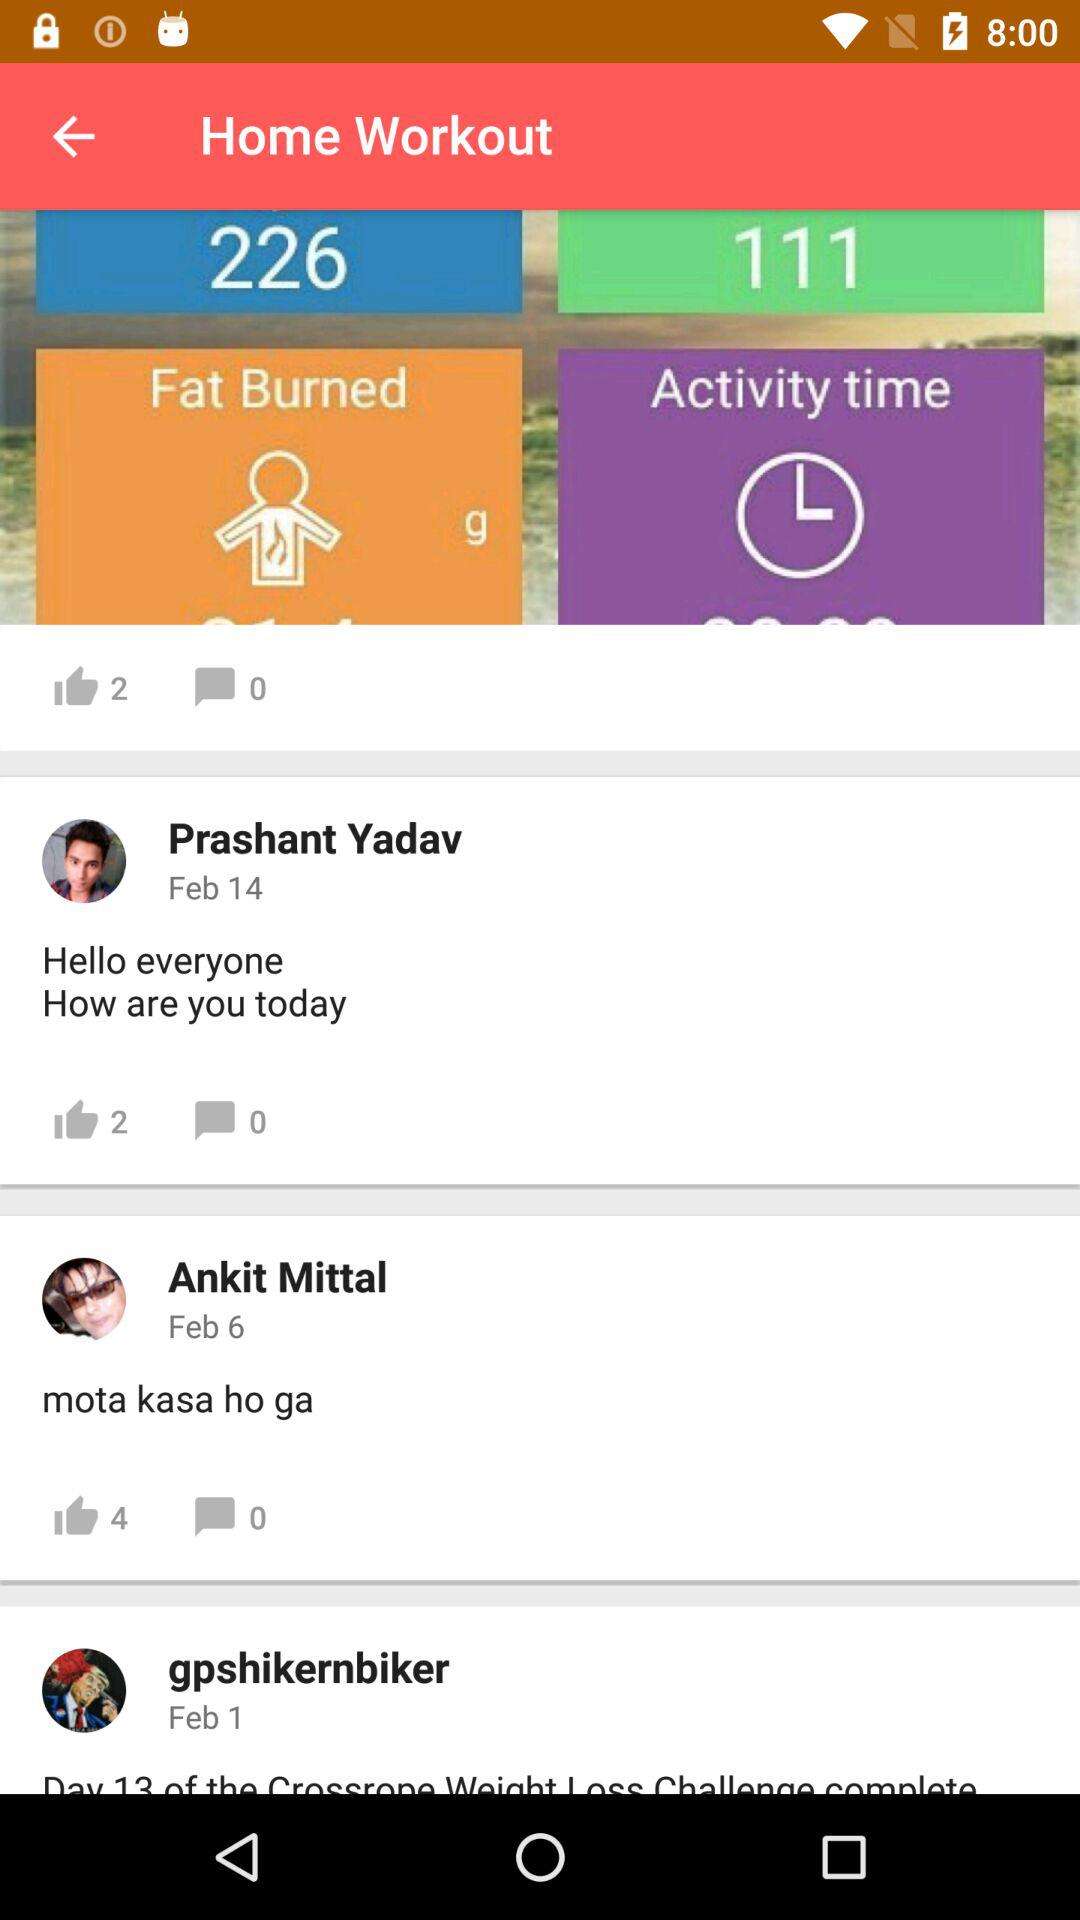How many likes are there on Ankit Mittal's comment? There are 4 likes on Ankit Mittal's comment. 